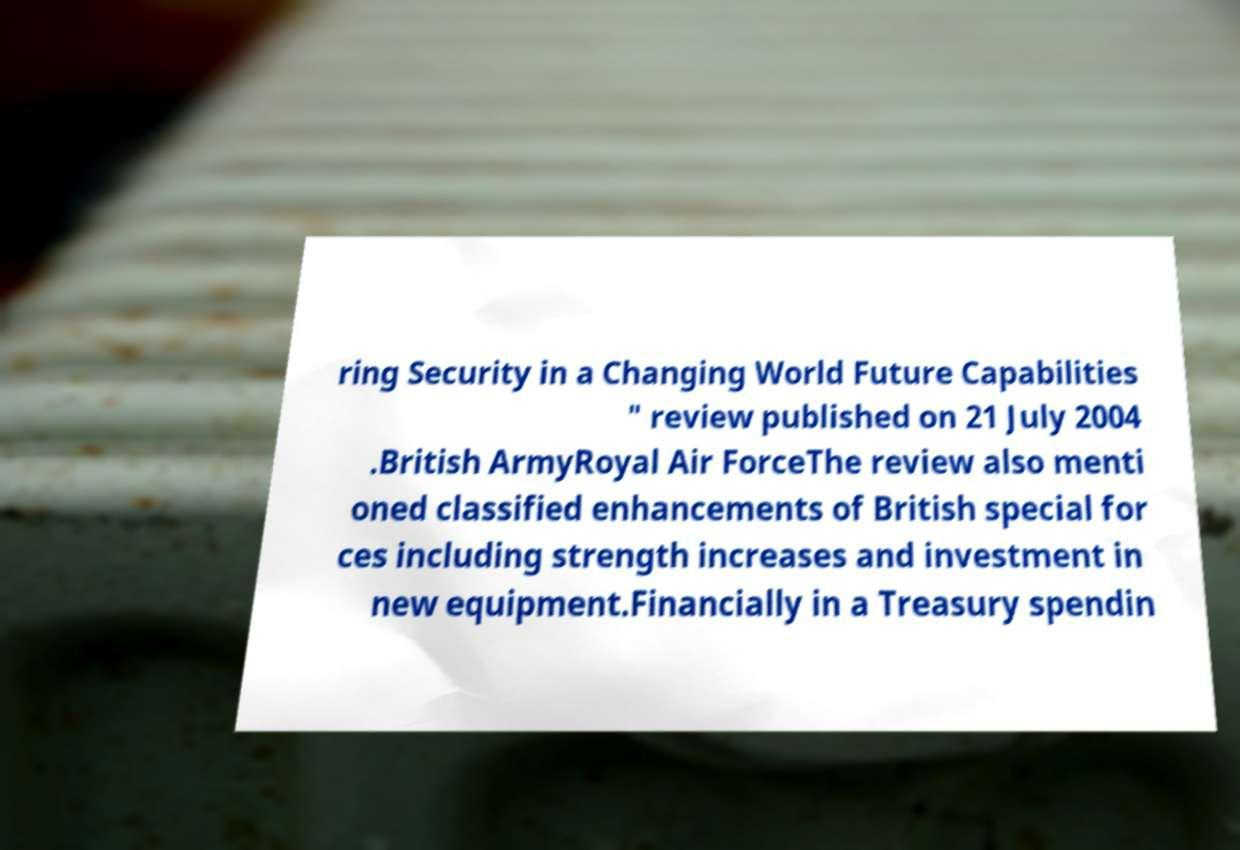For documentation purposes, I need the text within this image transcribed. Could you provide that? ring Security in a Changing World Future Capabilities " review published on 21 July 2004 .British ArmyRoyal Air ForceThe review also menti oned classified enhancements of British special for ces including strength increases and investment in new equipment.Financially in a Treasury spendin 